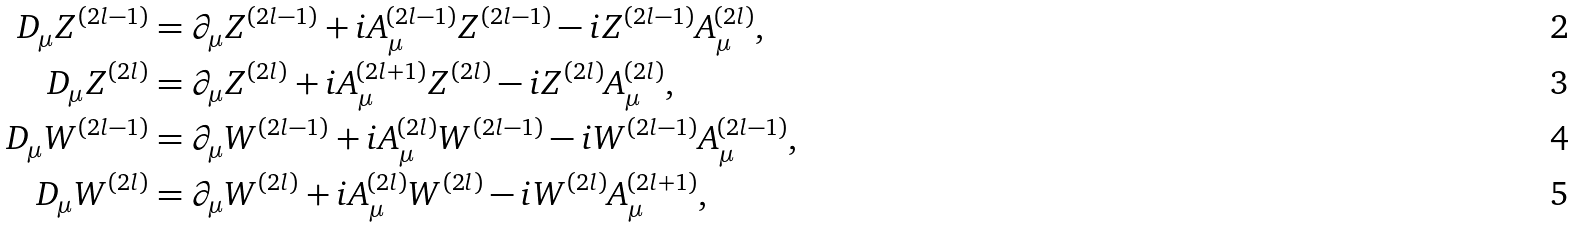Convert formula to latex. <formula><loc_0><loc_0><loc_500><loc_500>D _ { \mu } Z ^ { ( 2 l - 1 ) } & = \partial _ { \mu } Z ^ { ( 2 l - 1 ) } + i A ^ { ( 2 l - 1 ) } _ { \mu } Z ^ { ( 2 l - 1 ) } - i Z ^ { ( 2 l - 1 ) } A ^ { ( 2 l ) } _ { \mu } , \\ D _ { \mu } Z ^ { ( 2 l ) } & = \partial _ { \mu } Z ^ { ( 2 l ) } + i A ^ { ( 2 l + 1 ) } _ { \mu } Z ^ { ( 2 l ) } - i Z ^ { ( 2 l ) } A ^ { ( 2 l ) } _ { \mu } , \\ D _ { \mu } W ^ { ( 2 l - 1 ) } & = \partial _ { \mu } W ^ { ( 2 l - 1 ) } + i A ^ { ( 2 l ) } _ { \mu } W ^ { ( 2 l - 1 ) } - i W ^ { ( 2 l - 1 ) } A ^ { ( 2 l - 1 ) } _ { \mu } , \\ D _ { \mu } W ^ { ( 2 l ) } & = \partial _ { \mu } W ^ { ( 2 l ) } + i A ^ { ( 2 l ) } _ { \mu } W ^ { ( 2 l ) } - i W ^ { ( 2 l ) } A ^ { ( 2 l + 1 ) } _ { \mu } ,</formula> 